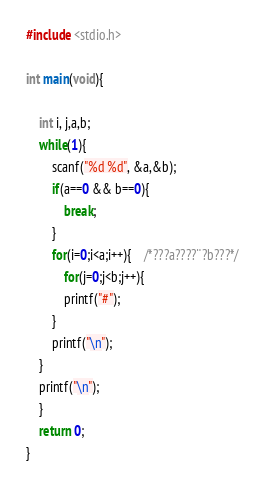<code> <loc_0><loc_0><loc_500><loc_500><_C_>#include <stdio.h>

int main(void){

	int i, j,a,b;
	while(1){
		scanf("%d %d", &a,&b);
		if(a==0 && b==0){
			break;
		}
		for(i=0;i<a;i++){	/*???a????¨?b???*/
			for(j=0;j<b;j++){
			printf("#");
		}
		printf("\n");
	}
	printf("\n");
	}
	return 0;
}</code> 